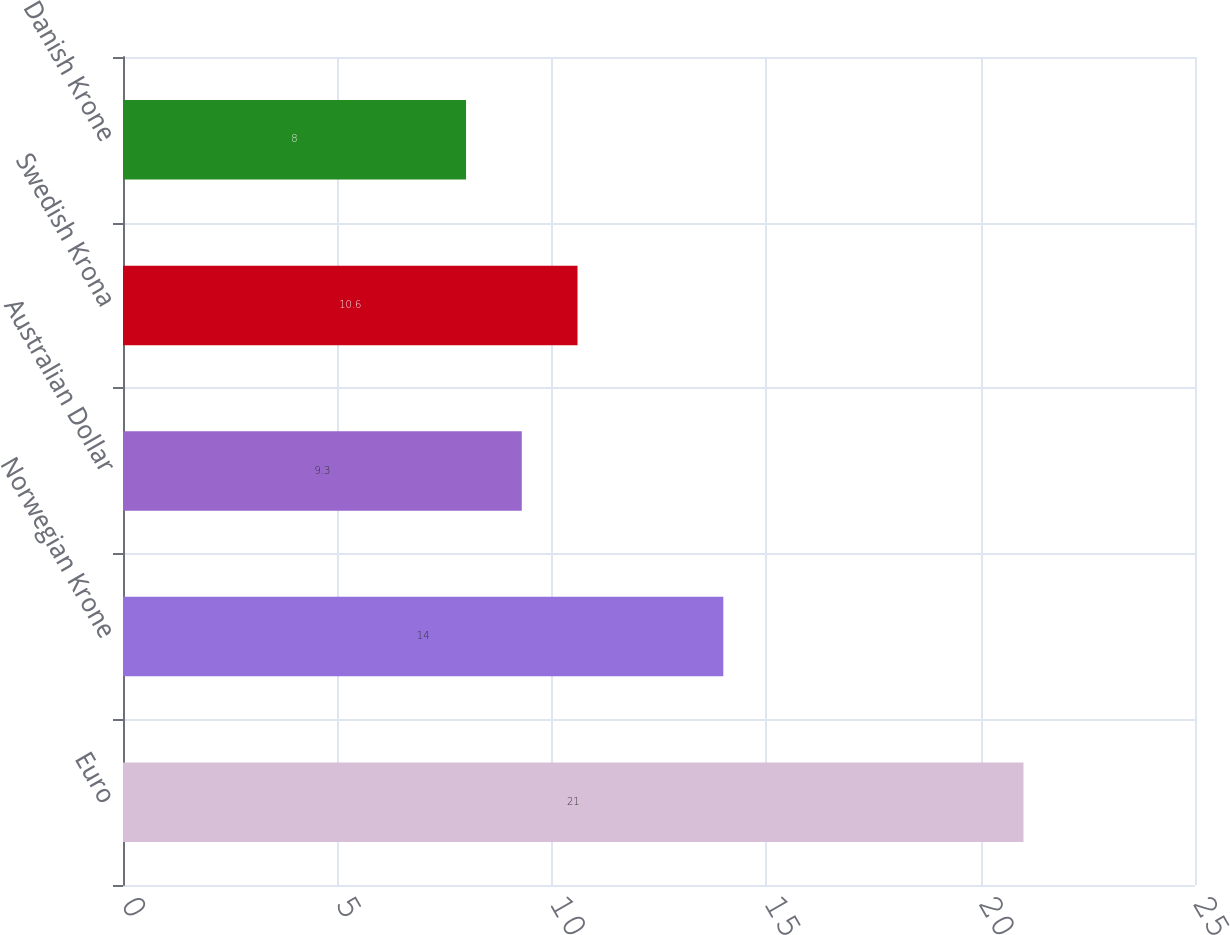<chart> <loc_0><loc_0><loc_500><loc_500><bar_chart><fcel>Euro<fcel>Norwegian Krone<fcel>Australian Dollar<fcel>Swedish Krona<fcel>Danish Krone<nl><fcel>21<fcel>14<fcel>9.3<fcel>10.6<fcel>8<nl></chart> 